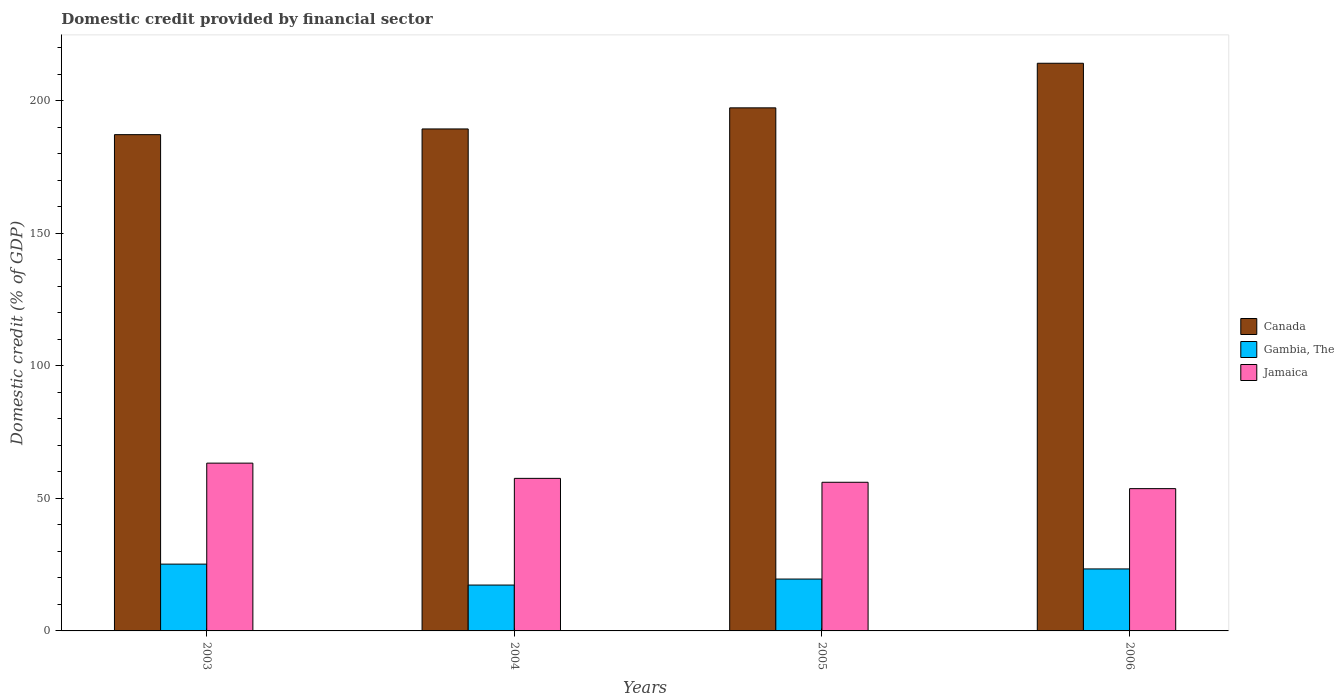Are the number of bars on each tick of the X-axis equal?
Offer a terse response. Yes. How many bars are there on the 2nd tick from the right?
Give a very brief answer. 3. What is the label of the 2nd group of bars from the left?
Your answer should be compact. 2004. What is the domestic credit in Jamaica in 2003?
Provide a succinct answer. 63.32. Across all years, what is the maximum domestic credit in Gambia, The?
Ensure brevity in your answer.  25.21. Across all years, what is the minimum domestic credit in Canada?
Make the answer very short. 187.29. In which year was the domestic credit in Canada minimum?
Offer a very short reply. 2003. What is the total domestic credit in Gambia, The in the graph?
Provide a succinct answer. 85.49. What is the difference between the domestic credit in Jamaica in 2003 and that in 2006?
Your response must be concise. 9.63. What is the difference between the domestic credit in Canada in 2005 and the domestic credit in Jamaica in 2003?
Provide a succinct answer. 134.08. What is the average domestic credit in Gambia, The per year?
Offer a terse response. 21.37. In the year 2006, what is the difference between the domestic credit in Canada and domestic credit in Jamaica?
Keep it short and to the point. 160.53. In how many years, is the domestic credit in Canada greater than 180 %?
Provide a short and direct response. 4. What is the ratio of the domestic credit in Canada in 2003 to that in 2004?
Provide a short and direct response. 0.99. Is the domestic credit in Jamaica in 2005 less than that in 2006?
Offer a terse response. No. Is the difference between the domestic credit in Canada in 2003 and 2005 greater than the difference between the domestic credit in Jamaica in 2003 and 2005?
Your response must be concise. No. What is the difference between the highest and the second highest domestic credit in Canada?
Offer a terse response. 16.83. What is the difference between the highest and the lowest domestic credit in Canada?
Make the answer very short. 26.94. In how many years, is the domestic credit in Jamaica greater than the average domestic credit in Jamaica taken over all years?
Offer a very short reply. 1. Is the sum of the domestic credit in Canada in 2003 and 2006 greater than the maximum domestic credit in Gambia, The across all years?
Make the answer very short. Yes. What does the 3rd bar from the left in 2006 represents?
Keep it short and to the point. Jamaica. What does the 2nd bar from the right in 2005 represents?
Offer a very short reply. Gambia, The. What is the difference between two consecutive major ticks on the Y-axis?
Your response must be concise. 50. Are the values on the major ticks of Y-axis written in scientific E-notation?
Offer a very short reply. No. What is the title of the graph?
Provide a succinct answer. Domestic credit provided by financial sector. Does "French Polynesia" appear as one of the legend labels in the graph?
Your answer should be very brief. No. What is the label or title of the Y-axis?
Give a very brief answer. Domestic credit (% of GDP). What is the Domestic credit (% of GDP) in Canada in 2003?
Provide a short and direct response. 187.29. What is the Domestic credit (% of GDP) in Gambia, The in 2003?
Offer a terse response. 25.21. What is the Domestic credit (% of GDP) in Jamaica in 2003?
Make the answer very short. 63.32. What is the Domestic credit (% of GDP) of Canada in 2004?
Your response must be concise. 189.44. What is the Domestic credit (% of GDP) of Gambia, The in 2004?
Offer a terse response. 17.31. What is the Domestic credit (% of GDP) of Jamaica in 2004?
Ensure brevity in your answer.  57.57. What is the Domestic credit (% of GDP) in Canada in 2005?
Your answer should be very brief. 197.4. What is the Domestic credit (% of GDP) in Gambia, The in 2005?
Make the answer very short. 19.57. What is the Domestic credit (% of GDP) in Jamaica in 2005?
Your response must be concise. 56.1. What is the Domestic credit (% of GDP) of Canada in 2006?
Offer a very short reply. 214.23. What is the Domestic credit (% of GDP) of Gambia, The in 2006?
Provide a short and direct response. 23.39. What is the Domestic credit (% of GDP) of Jamaica in 2006?
Your answer should be very brief. 53.69. Across all years, what is the maximum Domestic credit (% of GDP) of Canada?
Ensure brevity in your answer.  214.23. Across all years, what is the maximum Domestic credit (% of GDP) of Gambia, The?
Keep it short and to the point. 25.21. Across all years, what is the maximum Domestic credit (% of GDP) in Jamaica?
Offer a terse response. 63.32. Across all years, what is the minimum Domestic credit (% of GDP) in Canada?
Your answer should be very brief. 187.29. Across all years, what is the minimum Domestic credit (% of GDP) of Gambia, The?
Offer a very short reply. 17.31. Across all years, what is the minimum Domestic credit (% of GDP) of Jamaica?
Provide a short and direct response. 53.69. What is the total Domestic credit (% of GDP) in Canada in the graph?
Offer a terse response. 788.35. What is the total Domestic credit (% of GDP) in Gambia, The in the graph?
Keep it short and to the point. 85.49. What is the total Domestic credit (% of GDP) of Jamaica in the graph?
Your answer should be very brief. 230.68. What is the difference between the Domestic credit (% of GDP) in Canada in 2003 and that in 2004?
Offer a very short reply. -2.15. What is the difference between the Domestic credit (% of GDP) of Gambia, The in 2003 and that in 2004?
Offer a terse response. 7.9. What is the difference between the Domestic credit (% of GDP) of Jamaica in 2003 and that in 2004?
Make the answer very short. 5.75. What is the difference between the Domestic credit (% of GDP) of Canada in 2003 and that in 2005?
Make the answer very short. -10.11. What is the difference between the Domestic credit (% of GDP) in Gambia, The in 2003 and that in 2005?
Your answer should be compact. 5.64. What is the difference between the Domestic credit (% of GDP) of Jamaica in 2003 and that in 2005?
Ensure brevity in your answer.  7.22. What is the difference between the Domestic credit (% of GDP) in Canada in 2003 and that in 2006?
Keep it short and to the point. -26.94. What is the difference between the Domestic credit (% of GDP) in Gambia, The in 2003 and that in 2006?
Make the answer very short. 1.82. What is the difference between the Domestic credit (% of GDP) of Jamaica in 2003 and that in 2006?
Ensure brevity in your answer.  9.63. What is the difference between the Domestic credit (% of GDP) of Canada in 2004 and that in 2005?
Your response must be concise. -7.96. What is the difference between the Domestic credit (% of GDP) in Gambia, The in 2004 and that in 2005?
Provide a succinct answer. -2.26. What is the difference between the Domestic credit (% of GDP) of Jamaica in 2004 and that in 2005?
Keep it short and to the point. 1.47. What is the difference between the Domestic credit (% of GDP) in Canada in 2004 and that in 2006?
Make the answer very short. -24.79. What is the difference between the Domestic credit (% of GDP) in Gambia, The in 2004 and that in 2006?
Provide a short and direct response. -6.08. What is the difference between the Domestic credit (% of GDP) in Jamaica in 2004 and that in 2006?
Provide a short and direct response. 3.87. What is the difference between the Domestic credit (% of GDP) in Canada in 2005 and that in 2006?
Ensure brevity in your answer.  -16.83. What is the difference between the Domestic credit (% of GDP) of Gambia, The in 2005 and that in 2006?
Your response must be concise. -3.82. What is the difference between the Domestic credit (% of GDP) in Jamaica in 2005 and that in 2006?
Offer a very short reply. 2.4. What is the difference between the Domestic credit (% of GDP) of Canada in 2003 and the Domestic credit (% of GDP) of Gambia, The in 2004?
Offer a terse response. 169.98. What is the difference between the Domestic credit (% of GDP) of Canada in 2003 and the Domestic credit (% of GDP) of Jamaica in 2004?
Keep it short and to the point. 129.72. What is the difference between the Domestic credit (% of GDP) in Gambia, The in 2003 and the Domestic credit (% of GDP) in Jamaica in 2004?
Provide a succinct answer. -32.36. What is the difference between the Domestic credit (% of GDP) of Canada in 2003 and the Domestic credit (% of GDP) of Gambia, The in 2005?
Your response must be concise. 167.71. What is the difference between the Domestic credit (% of GDP) of Canada in 2003 and the Domestic credit (% of GDP) of Jamaica in 2005?
Offer a very short reply. 131.19. What is the difference between the Domestic credit (% of GDP) of Gambia, The in 2003 and the Domestic credit (% of GDP) of Jamaica in 2005?
Keep it short and to the point. -30.88. What is the difference between the Domestic credit (% of GDP) in Canada in 2003 and the Domestic credit (% of GDP) in Gambia, The in 2006?
Keep it short and to the point. 163.89. What is the difference between the Domestic credit (% of GDP) in Canada in 2003 and the Domestic credit (% of GDP) in Jamaica in 2006?
Offer a terse response. 133.59. What is the difference between the Domestic credit (% of GDP) in Gambia, The in 2003 and the Domestic credit (% of GDP) in Jamaica in 2006?
Your response must be concise. -28.48. What is the difference between the Domestic credit (% of GDP) in Canada in 2004 and the Domestic credit (% of GDP) in Gambia, The in 2005?
Ensure brevity in your answer.  169.86. What is the difference between the Domestic credit (% of GDP) of Canada in 2004 and the Domestic credit (% of GDP) of Jamaica in 2005?
Provide a succinct answer. 133.34. What is the difference between the Domestic credit (% of GDP) of Gambia, The in 2004 and the Domestic credit (% of GDP) of Jamaica in 2005?
Make the answer very short. -38.79. What is the difference between the Domestic credit (% of GDP) of Canada in 2004 and the Domestic credit (% of GDP) of Gambia, The in 2006?
Offer a very short reply. 166.04. What is the difference between the Domestic credit (% of GDP) of Canada in 2004 and the Domestic credit (% of GDP) of Jamaica in 2006?
Give a very brief answer. 135.74. What is the difference between the Domestic credit (% of GDP) in Gambia, The in 2004 and the Domestic credit (% of GDP) in Jamaica in 2006?
Offer a very short reply. -36.39. What is the difference between the Domestic credit (% of GDP) of Canada in 2005 and the Domestic credit (% of GDP) of Gambia, The in 2006?
Provide a short and direct response. 174. What is the difference between the Domestic credit (% of GDP) in Canada in 2005 and the Domestic credit (% of GDP) in Jamaica in 2006?
Give a very brief answer. 143.7. What is the difference between the Domestic credit (% of GDP) in Gambia, The in 2005 and the Domestic credit (% of GDP) in Jamaica in 2006?
Offer a terse response. -34.12. What is the average Domestic credit (% of GDP) of Canada per year?
Offer a very short reply. 197.09. What is the average Domestic credit (% of GDP) of Gambia, The per year?
Ensure brevity in your answer.  21.37. What is the average Domestic credit (% of GDP) of Jamaica per year?
Give a very brief answer. 57.67. In the year 2003, what is the difference between the Domestic credit (% of GDP) in Canada and Domestic credit (% of GDP) in Gambia, The?
Offer a terse response. 162.07. In the year 2003, what is the difference between the Domestic credit (% of GDP) of Canada and Domestic credit (% of GDP) of Jamaica?
Keep it short and to the point. 123.97. In the year 2003, what is the difference between the Domestic credit (% of GDP) of Gambia, The and Domestic credit (% of GDP) of Jamaica?
Make the answer very short. -38.11. In the year 2004, what is the difference between the Domestic credit (% of GDP) of Canada and Domestic credit (% of GDP) of Gambia, The?
Make the answer very short. 172.13. In the year 2004, what is the difference between the Domestic credit (% of GDP) in Canada and Domestic credit (% of GDP) in Jamaica?
Make the answer very short. 131.87. In the year 2004, what is the difference between the Domestic credit (% of GDP) in Gambia, The and Domestic credit (% of GDP) in Jamaica?
Ensure brevity in your answer.  -40.26. In the year 2005, what is the difference between the Domestic credit (% of GDP) of Canada and Domestic credit (% of GDP) of Gambia, The?
Offer a very short reply. 177.82. In the year 2005, what is the difference between the Domestic credit (% of GDP) of Canada and Domestic credit (% of GDP) of Jamaica?
Provide a short and direct response. 141.3. In the year 2005, what is the difference between the Domestic credit (% of GDP) of Gambia, The and Domestic credit (% of GDP) of Jamaica?
Your answer should be compact. -36.52. In the year 2006, what is the difference between the Domestic credit (% of GDP) of Canada and Domestic credit (% of GDP) of Gambia, The?
Keep it short and to the point. 190.83. In the year 2006, what is the difference between the Domestic credit (% of GDP) of Canada and Domestic credit (% of GDP) of Jamaica?
Your answer should be very brief. 160.53. In the year 2006, what is the difference between the Domestic credit (% of GDP) of Gambia, The and Domestic credit (% of GDP) of Jamaica?
Offer a very short reply. -30.3. What is the ratio of the Domestic credit (% of GDP) of Canada in 2003 to that in 2004?
Your response must be concise. 0.99. What is the ratio of the Domestic credit (% of GDP) of Gambia, The in 2003 to that in 2004?
Provide a short and direct response. 1.46. What is the ratio of the Domestic credit (% of GDP) of Jamaica in 2003 to that in 2004?
Ensure brevity in your answer.  1.1. What is the ratio of the Domestic credit (% of GDP) in Canada in 2003 to that in 2005?
Your answer should be very brief. 0.95. What is the ratio of the Domestic credit (% of GDP) in Gambia, The in 2003 to that in 2005?
Offer a terse response. 1.29. What is the ratio of the Domestic credit (% of GDP) in Jamaica in 2003 to that in 2005?
Make the answer very short. 1.13. What is the ratio of the Domestic credit (% of GDP) of Canada in 2003 to that in 2006?
Offer a very short reply. 0.87. What is the ratio of the Domestic credit (% of GDP) of Gambia, The in 2003 to that in 2006?
Offer a very short reply. 1.08. What is the ratio of the Domestic credit (% of GDP) in Jamaica in 2003 to that in 2006?
Provide a short and direct response. 1.18. What is the ratio of the Domestic credit (% of GDP) in Canada in 2004 to that in 2005?
Give a very brief answer. 0.96. What is the ratio of the Domestic credit (% of GDP) of Gambia, The in 2004 to that in 2005?
Keep it short and to the point. 0.88. What is the ratio of the Domestic credit (% of GDP) of Jamaica in 2004 to that in 2005?
Keep it short and to the point. 1.03. What is the ratio of the Domestic credit (% of GDP) in Canada in 2004 to that in 2006?
Keep it short and to the point. 0.88. What is the ratio of the Domestic credit (% of GDP) in Gambia, The in 2004 to that in 2006?
Keep it short and to the point. 0.74. What is the ratio of the Domestic credit (% of GDP) in Jamaica in 2004 to that in 2006?
Make the answer very short. 1.07. What is the ratio of the Domestic credit (% of GDP) of Canada in 2005 to that in 2006?
Provide a short and direct response. 0.92. What is the ratio of the Domestic credit (% of GDP) of Gambia, The in 2005 to that in 2006?
Give a very brief answer. 0.84. What is the ratio of the Domestic credit (% of GDP) in Jamaica in 2005 to that in 2006?
Your answer should be compact. 1.04. What is the difference between the highest and the second highest Domestic credit (% of GDP) of Canada?
Provide a succinct answer. 16.83. What is the difference between the highest and the second highest Domestic credit (% of GDP) in Gambia, The?
Offer a very short reply. 1.82. What is the difference between the highest and the second highest Domestic credit (% of GDP) in Jamaica?
Provide a short and direct response. 5.75. What is the difference between the highest and the lowest Domestic credit (% of GDP) of Canada?
Give a very brief answer. 26.94. What is the difference between the highest and the lowest Domestic credit (% of GDP) in Gambia, The?
Your answer should be compact. 7.9. What is the difference between the highest and the lowest Domestic credit (% of GDP) in Jamaica?
Keep it short and to the point. 9.63. 